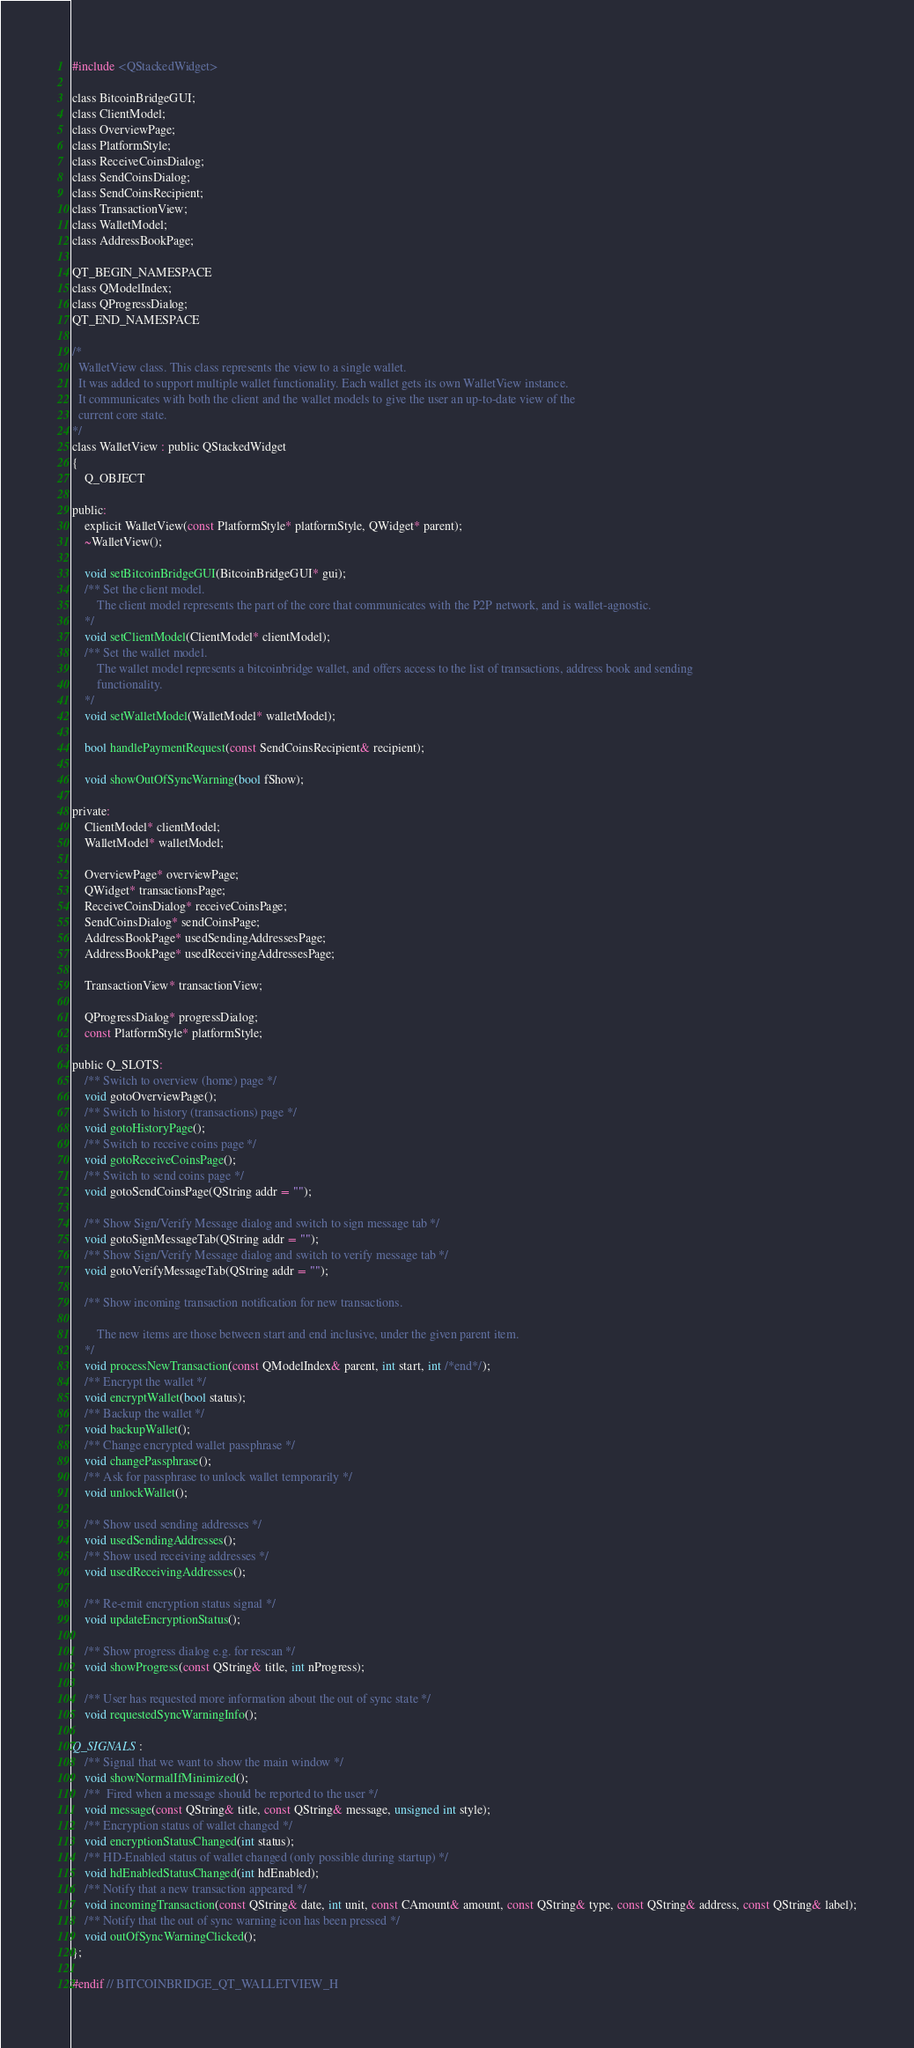Convert code to text. <code><loc_0><loc_0><loc_500><loc_500><_C_>
#include <QStackedWidget>

class BitcoinBridgeGUI;
class ClientModel;
class OverviewPage;
class PlatformStyle;
class ReceiveCoinsDialog;
class SendCoinsDialog;
class SendCoinsRecipient;
class TransactionView;
class WalletModel;
class AddressBookPage;

QT_BEGIN_NAMESPACE
class QModelIndex;
class QProgressDialog;
QT_END_NAMESPACE

/*
  WalletView class. This class represents the view to a single wallet.
  It was added to support multiple wallet functionality. Each wallet gets its own WalletView instance.
  It communicates with both the client and the wallet models to give the user an up-to-date view of the
  current core state.
*/
class WalletView : public QStackedWidget
{
    Q_OBJECT

public:
    explicit WalletView(const PlatformStyle* platformStyle, QWidget* parent);
    ~WalletView();

    void setBitcoinBridgeGUI(BitcoinBridgeGUI* gui);
    /** Set the client model.
        The client model represents the part of the core that communicates with the P2P network, and is wallet-agnostic.
    */
    void setClientModel(ClientModel* clientModel);
    /** Set the wallet model.
        The wallet model represents a bitcoinbridge wallet, and offers access to the list of transactions, address book and sending
        functionality.
    */
    void setWalletModel(WalletModel* walletModel);

    bool handlePaymentRequest(const SendCoinsRecipient& recipient);

    void showOutOfSyncWarning(bool fShow);

private:
    ClientModel* clientModel;
    WalletModel* walletModel;

    OverviewPage* overviewPage;
    QWidget* transactionsPage;
    ReceiveCoinsDialog* receiveCoinsPage;
    SendCoinsDialog* sendCoinsPage;
    AddressBookPage* usedSendingAddressesPage;
    AddressBookPage* usedReceivingAddressesPage;

    TransactionView* transactionView;

    QProgressDialog* progressDialog;
    const PlatformStyle* platformStyle;

public Q_SLOTS:
    /** Switch to overview (home) page */
    void gotoOverviewPage();
    /** Switch to history (transactions) page */
    void gotoHistoryPage();
    /** Switch to receive coins page */
    void gotoReceiveCoinsPage();
    /** Switch to send coins page */
    void gotoSendCoinsPage(QString addr = "");

    /** Show Sign/Verify Message dialog and switch to sign message tab */
    void gotoSignMessageTab(QString addr = "");
    /** Show Sign/Verify Message dialog and switch to verify message tab */
    void gotoVerifyMessageTab(QString addr = "");

    /** Show incoming transaction notification for new transactions.

        The new items are those between start and end inclusive, under the given parent item.
    */
    void processNewTransaction(const QModelIndex& parent, int start, int /*end*/);
    /** Encrypt the wallet */
    void encryptWallet(bool status);
    /** Backup the wallet */
    void backupWallet();
    /** Change encrypted wallet passphrase */
    void changePassphrase();
    /** Ask for passphrase to unlock wallet temporarily */
    void unlockWallet();

    /** Show used sending addresses */
    void usedSendingAddresses();
    /** Show used receiving addresses */
    void usedReceivingAddresses();

    /** Re-emit encryption status signal */
    void updateEncryptionStatus();

    /** Show progress dialog e.g. for rescan */
    void showProgress(const QString& title, int nProgress);

    /** User has requested more information about the out of sync state */
    void requestedSyncWarningInfo();

Q_SIGNALS:
    /** Signal that we want to show the main window */
    void showNormalIfMinimized();
    /**  Fired when a message should be reported to the user */
    void message(const QString& title, const QString& message, unsigned int style);
    /** Encryption status of wallet changed */
    void encryptionStatusChanged(int status);
    /** HD-Enabled status of wallet changed (only possible during startup) */
    void hdEnabledStatusChanged(int hdEnabled);
    /** Notify that a new transaction appeared */
    void incomingTransaction(const QString& date, int unit, const CAmount& amount, const QString& type, const QString& address, const QString& label);
    /** Notify that the out of sync warning icon has been pressed */
    void outOfSyncWarningClicked();
};

#endif // BITCOINBRIDGE_QT_WALLETVIEW_H
</code> 